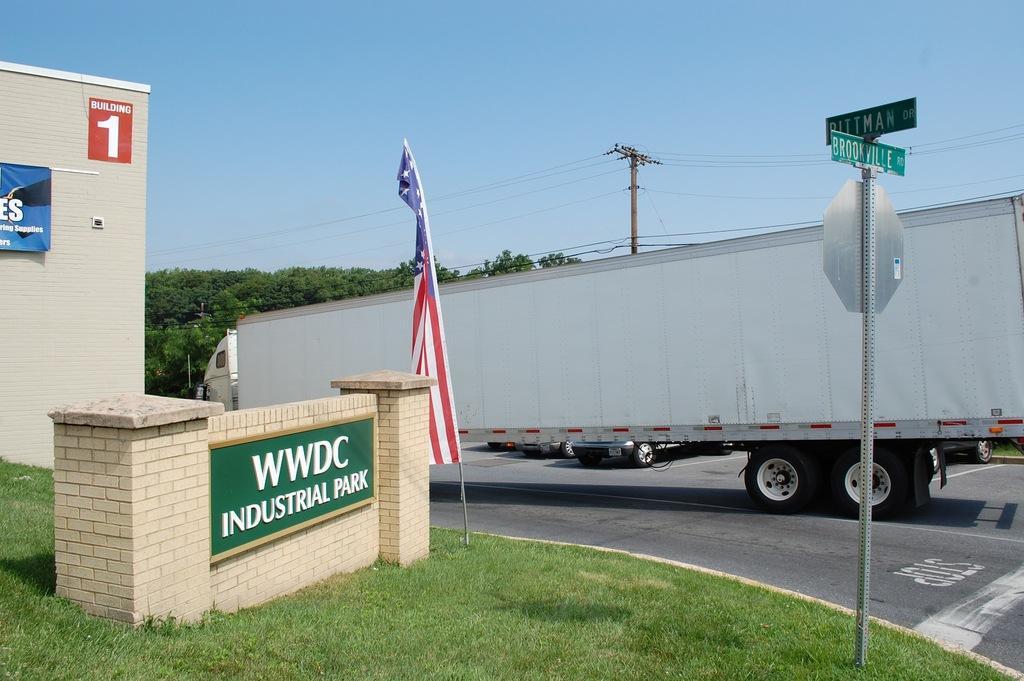In one or two sentences, can you explain what this image depicts? In this image we can see motor vehicles on the road, poles, name boards, sign boards, flag, building, trees, electric poles, electric cables and sky. 